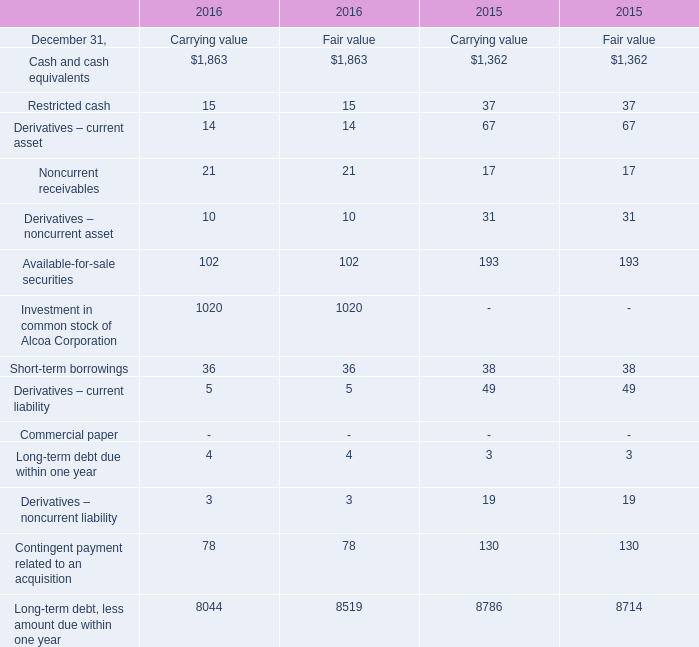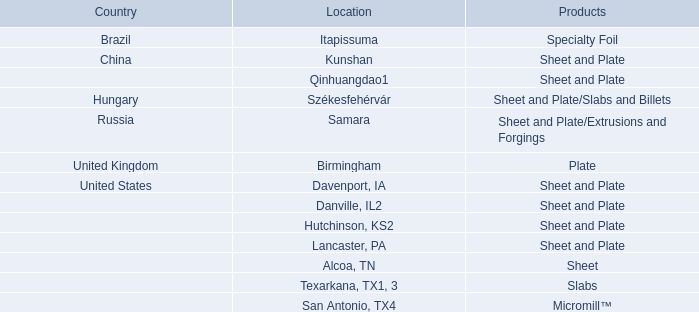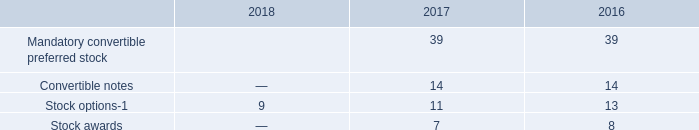What is the sum of Cash and cash equivalents, Restricted cash and Derivatives – current asset in 2016? 
Computations: (((((1863 + 15) + 14) + 1863) + 15) + 14)
Answer: 3784.0. 